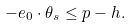Convert formula to latex. <formula><loc_0><loc_0><loc_500><loc_500>- e _ { 0 } \cdot \theta _ { s } \leq p - h .</formula> 